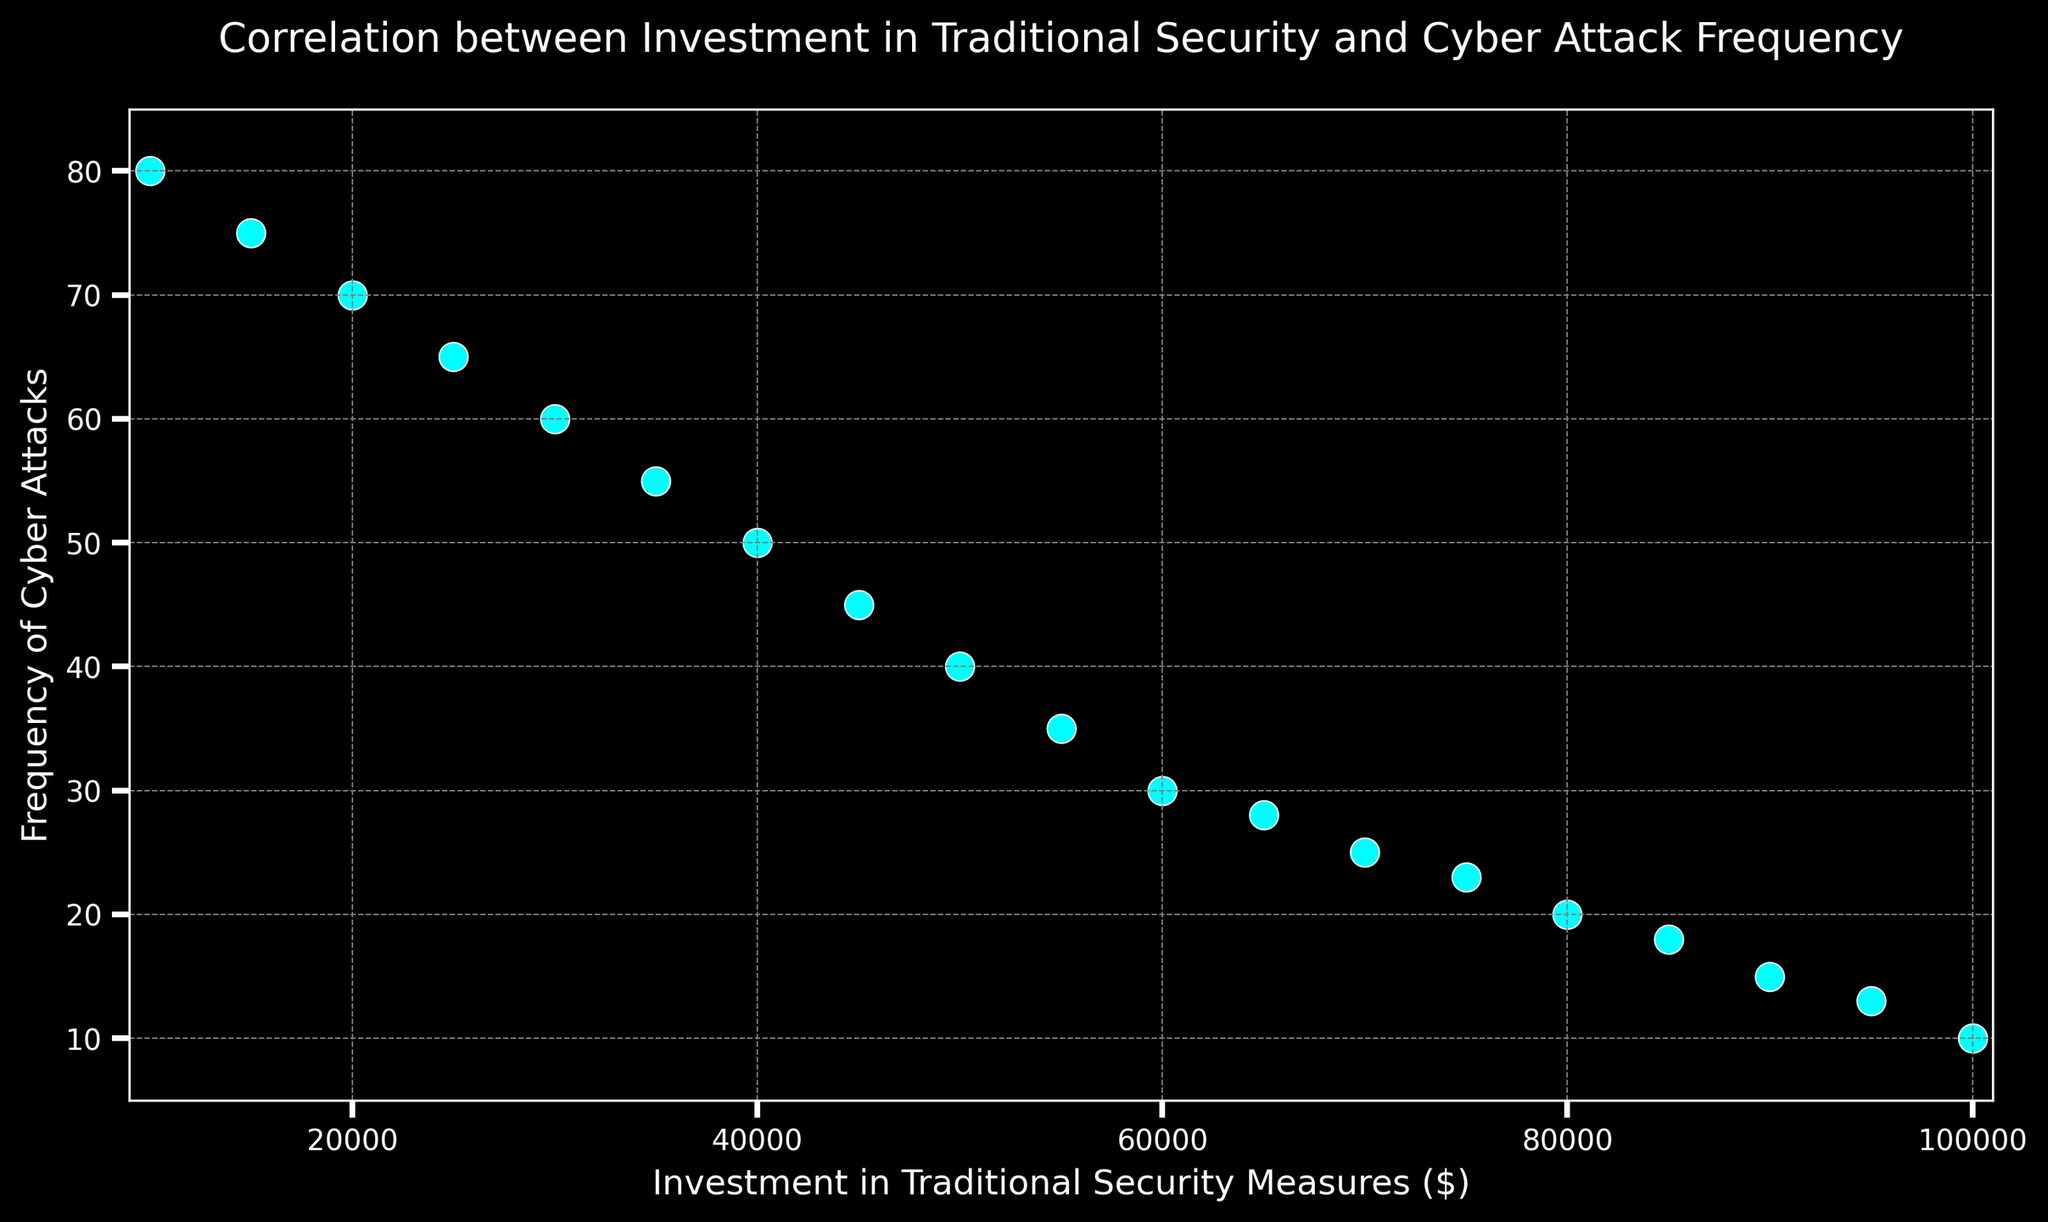What's the general trend observed between investment in traditional security measures and the frequency of cyber attacks? The scatter plot shows that as the investment in traditional security measures increases, the frequency of cyber attacks decreases. This negative correlation indicates that higher investments in security are associated with fewer cyber attacks.
Answer: Negative correlation What is the frequency of cyber attacks when the investment in traditional security measures is $50,000? By looking at the scatter plot, we find the data point corresponding to an investment of $50,000. The frequency of cyber attacks at that investment level is 40.
Answer: 40 How many data points are plotted in the scatter plot? To determine the number of data points, count the individual markers on the scatter plot. Since each investment value corresponds to a unique frequency, we count 19 markers.
Answer: 19 Which investment value corresponds to the lowest frequency of cyber attacks, and what is that frequency? By examining the scatter plot, the lowest frequency of cyber attacks is 10, and this value corresponds to an investment of $100,000 in traditional security measures.
Answer: $100,000 and 10 Does any investment level correspond to a frequency of cyber attacks greater than 70? Looking at the scatter plot, the highest frequency of cyber attacks is 80, which corresponds to an investment of $10,000. No other investments exceed the frequency of 70.
Answer: Yes, at $10,000 What's the difference in the frequency of cyber attacks between the lowest and highest investment levels shown? The lowest investment level is $10,000 corresponding to 80 attacks, and the highest is $100,000 corresponding to 10 attacks. The difference is 80 - 10 = 70.
Answer: 70 Identify the investment level where the frequency of cyber attacks begins to drop below 30. Inspecting the scatter plot, the frequency of cyber attacks drops below 30 when the investment reaches $60,000.
Answer: $60,000 If the investment is increased from $30,000 to $70,000, how much does the frequency of cyber attacks decrease by? At $30,000, the frequency is 60. At $70,000, it is 25. Therefore, the decrease is 60 - 25 = 35.
Answer: 35 Is there any investment level at which the frequency of cyber attacks remains unchanged? Observing the scatter plot, each investment level is associated with a unique frequency, indicating continuous change. Therefore, no investment level leaves the frequency of cyber attacks unchanged.
Answer: No 